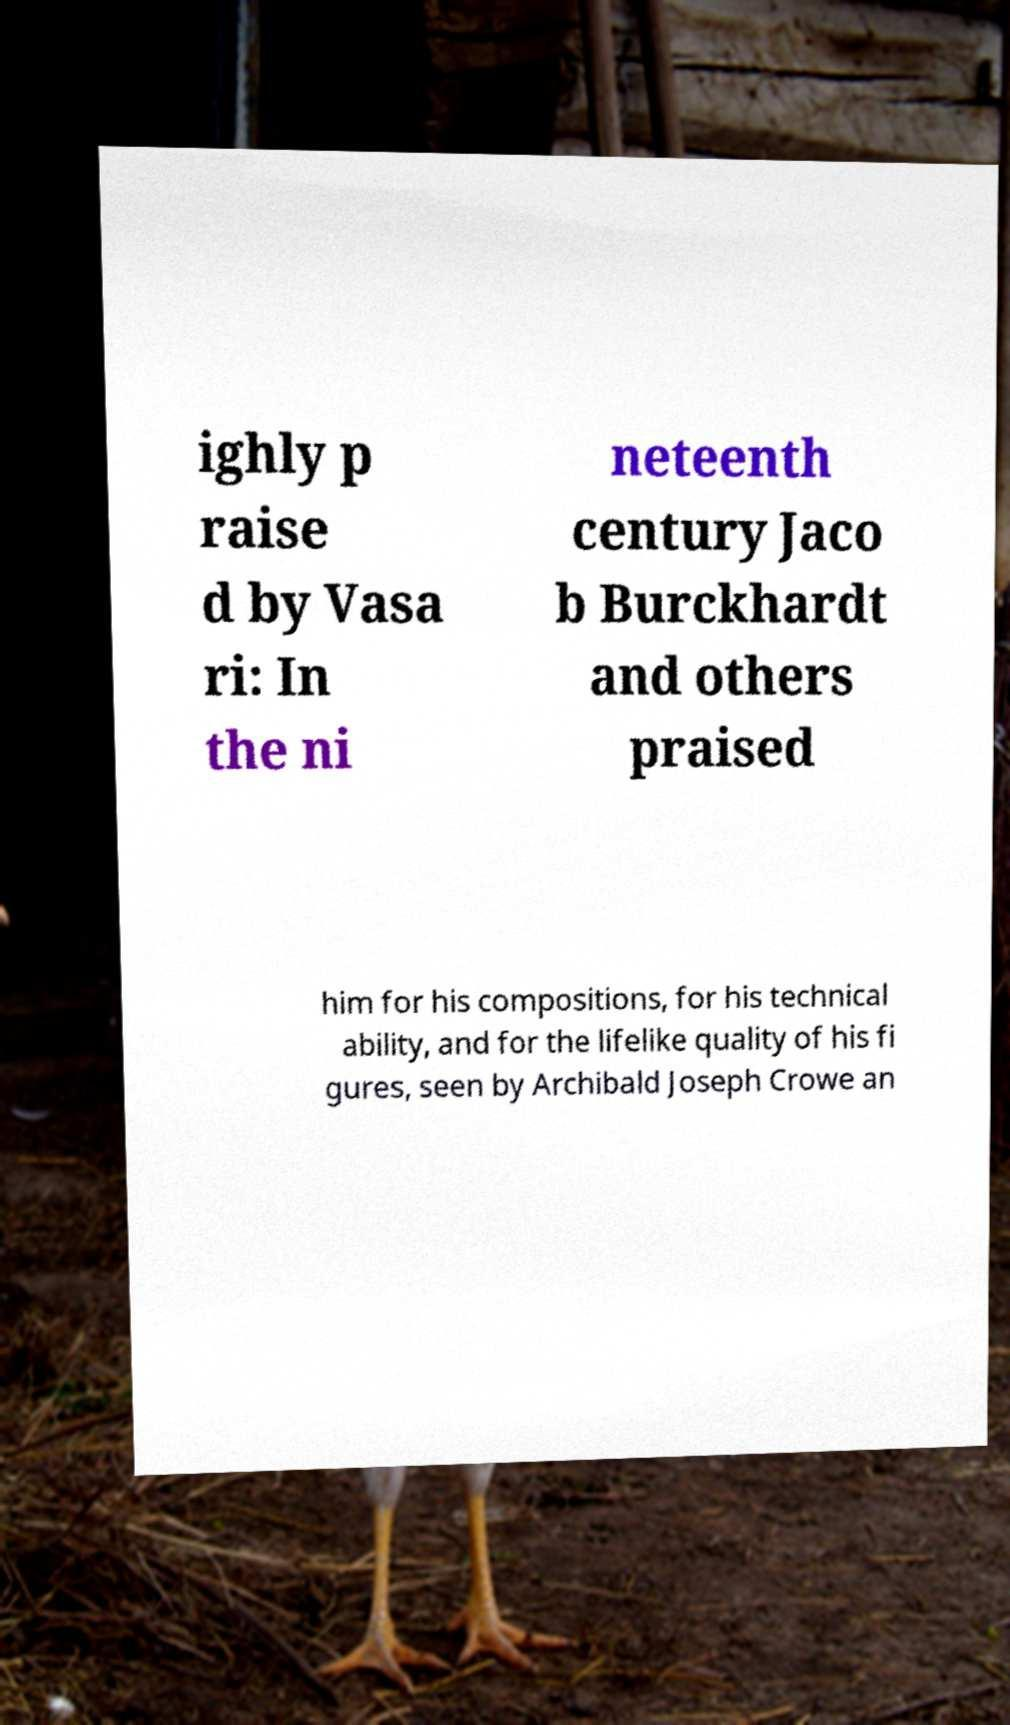What messages or text are displayed in this image? I need them in a readable, typed format. ighly p raise d by Vasa ri: In the ni neteenth century Jaco b Burckhardt and others praised him for his compositions, for his technical ability, and for the lifelike quality of his fi gures, seen by Archibald Joseph Crowe an 